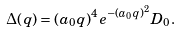<formula> <loc_0><loc_0><loc_500><loc_500>\Delta ( q ) = ( a _ { 0 } q ) ^ { 4 } e ^ { - ( a _ { 0 } q ) ^ { 2 } } D _ { 0 } .</formula> 